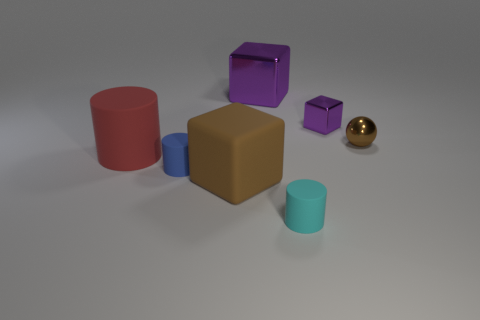There is a big cube that is right of the big brown object; is it the same color as the small metallic cube?
Your answer should be compact. Yes. What size is the rubber block?
Provide a succinct answer. Large. There is a cylinder that is behind the tiny rubber object that is to the left of the small cyan cylinder; how big is it?
Your response must be concise. Large. What shape is the other purple thing that is made of the same material as the large purple object?
Keep it short and to the point. Cube. Is there anything else that has the same color as the big rubber cylinder?
Offer a terse response. No. The matte block that is the same color as the tiny metal sphere is what size?
Your answer should be very brief. Large. Are there more cyan matte things that are on the left side of the brown ball than large green matte spheres?
Provide a succinct answer. Yes. There is a big purple object; is its shape the same as the purple metal object to the right of the cyan matte cylinder?
Your answer should be compact. Yes. How many other rubber blocks are the same size as the brown block?
Offer a terse response. 0. There is a small cylinder that is in front of the brown thing on the left side of the ball; what number of objects are left of it?
Keep it short and to the point. 4. 